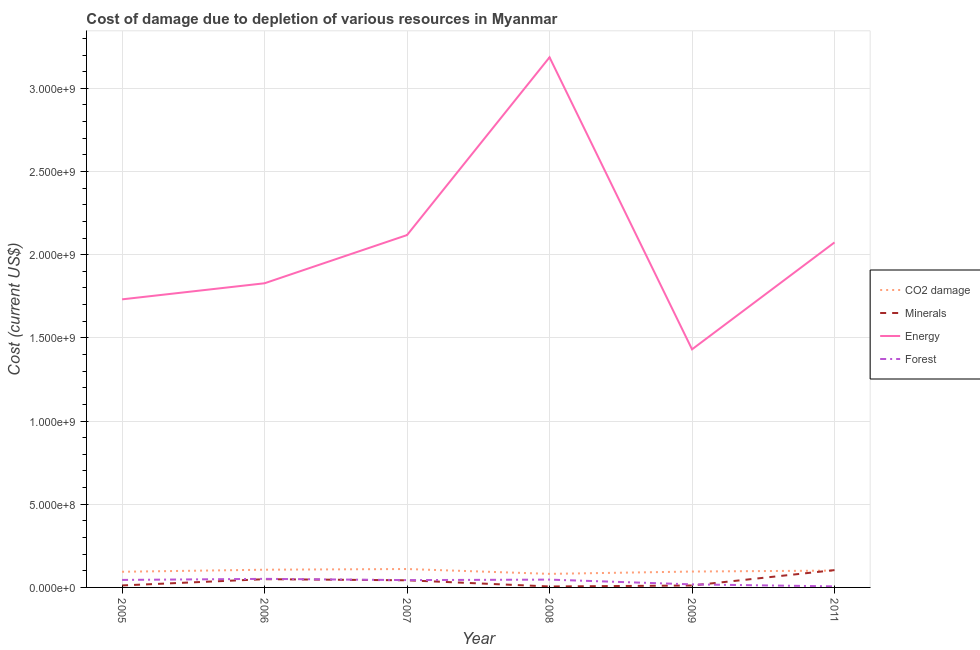How many different coloured lines are there?
Ensure brevity in your answer.  4. What is the cost of damage due to depletion of coal in 2008?
Give a very brief answer. 8.15e+07. Across all years, what is the maximum cost of damage due to depletion of minerals?
Your answer should be compact. 1.04e+08. Across all years, what is the minimum cost of damage due to depletion of minerals?
Provide a short and direct response. 5.68e+06. In which year was the cost of damage due to depletion of forests minimum?
Your answer should be compact. 2011. What is the total cost of damage due to depletion of energy in the graph?
Give a very brief answer. 1.24e+1. What is the difference between the cost of damage due to depletion of forests in 2006 and that in 2007?
Offer a terse response. 7.51e+06. What is the difference between the cost of damage due to depletion of forests in 2009 and the cost of damage due to depletion of minerals in 2006?
Keep it short and to the point. -3.12e+07. What is the average cost of damage due to depletion of forests per year?
Your response must be concise. 3.54e+07. In the year 2005, what is the difference between the cost of damage due to depletion of energy and cost of damage due to depletion of coal?
Give a very brief answer. 1.64e+09. In how many years, is the cost of damage due to depletion of coal greater than 2000000000 US$?
Offer a terse response. 0. What is the ratio of the cost of damage due to depletion of coal in 2006 to that in 2008?
Ensure brevity in your answer.  1.31. Is the cost of damage due to depletion of minerals in 2007 less than that in 2008?
Provide a short and direct response. No. Is the difference between the cost of damage due to depletion of coal in 2007 and 2011 greater than the difference between the cost of damage due to depletion of forests in 2007 and 2011?
Keep it short and to the point. No. What is the difference between the highest and the second highest cost of damage due to depletion of coal?
Give a very brief answer. 4.21e+06. What is the difference between the highest and the lowest cost of damage due to depletion of coal?
Ensure brevity in your answer.  2.92e+07. Is it the case that in every year, the sum of the cost of damage due to depletion of coal and cost of damage due to depletion of minerals is greater than the cost of damage due to depletion of energy?
Make the answer very short. No. Is the cost of damage due to depletion of minerals strictly greater than the cost of damage due to depletion of forests over the years?
Your answer should be compact. No. Is the cost of damage due to depletion of coal strictly less than the cost of damage due to depletion of energy over the years?
Provide a short and direct response. Yes. How many years are there in the graph?
Your answer should be very brief. 6. Are the values on the major ticks of Y-axis written in scientific E-notation?
Provide a short and direct response. Yes. How are the legend labels stacked?
Give a very brief answer. Vertical. What is the title of the graph?
Provide a succinct answer. Cost of damage due to depletion of various resources in Myanmar . What is the label or title of the Y-axis?
Keep it short and to the point. Cost (current US$). What is the Cost (current US$) in CO2 damage in 2005?
Provide a succinct answer. 9.41e+07. What is the Cost (current US$) in Minerals in 2005?
Keep it short and to the point. 1.19e+07. What is the Cost (current US$) in Energy in 2005?
Offer a terse response. 1.73e+09. What is the Cost (current US$) of Forest in 2005?
Your answer should be compact. 4.51e+07. What is the Cost (current US$) of CO2 damage in 2006?
Your answer should be compact. 1.06e+08. What is the Cost (current US$) in Minerals in 2006?
Offer a terse response. 4.95e+07. What is the Cost (current US$) in Energy in 2006?
Your answer should be compact. 1.83e+09. What is the Cost (current US$) in Forest in 2006?
Offer a very short reply. 5.15e+07. What is the Cost (current US$) of CO2 damage in 2007?
Provide a short and direct response. 1.11e+08. What is the Cost (current US$) of Minerals in 2007?
Your response must be concise. 4.29e+07. What is the Cost (current US$) of Energy in 2007?
Your response must be concise. 2.12e+09. What is the Cost (current US$) of Forest in 2007?
Keep it short and to the point. 4.40e+07. What is the Cost (current US$) of CO2 damage in 2008?
Ensure brevity in your answer.  8.15e+07. What is the Cost (current US$) of Minerals in 2008?
Provide a short and direct response. 5.68e+06. What is the Cost (current US$) in Energy in 2008?
Provide a short and direct response. 3.19e+09. What is the Cost (current US$) in Forest in 2008?
Your answer should be very brief. 4.70e+07. What is the Cost (current US$) of CO2 damage in 2009?
Offer a very short reply. 9.55e+07. What is the Cost (current US$) of Minerals in 2009?
Keep it short and to the point. 1.15e+07. What is the Cost (current US$) in Energy in 2009?
Provide a succinct answer. 1.43e+09. What is the Cost (current US$) in Forest in 2009?
Provide a short and direct response. 1.83e+07. What is the Cost (current US$) of CO2 damage in 2011?
Ensure brevity in your answer.  1.01e+08. What is the Cost (current US$) of Minerals in 2011?
Your answer should be compact. 1.04e+08. What is the Cost (current US$) of Energy in 2011?
Provide a short and direct response. 2.07e+09. What is the Cost (current US$) in Forest in 2011?
Your answer should be compact. 6.26e+06. Across all years, what is the maximum Cost (current US$) in CO2 damage?
Offer a terse response. 1.11e+08. Across all years, what is the maximum Cost (current US$) of Minerals?
Make the answer very short. 1.04e+08. Across all years, what is the maximum Cost (current US$) of Energy?
Make the answer very short. 3.19e+09. Across all years, what is the maximum Cost (current US$) of Forest?
Offer a very short reply. 5.15e+07. Across all years, what is the minimum Cost (current US$) in CO2 damage?
Your answer should be compact. 8.15e+07. Across all years, what is the minimum Cost (current US$) in Minerals?
Offer a terse response. 5.68e+06. Across all years, what is the minimum Cost (current US$) of Energy?
Give a very brief answer. 1.43e+09. Across all years, what is the minimum Cost (current US$) of Forest?
Offer a very short reply. 6.26e+06. What is the total Cost (current US$) of CO2 damage in the graph?
Make the answer very short. 5.89e+08. What is the total Cost (current US$) of Minerals in the graph?
Your answer should be very brief. 2.26e+08. What is the total Cost (current US$) of Energy in the graph?
Offer a very short reply. 1.24e+1. What is the total Cost (current US$) of Forest in the graph?
Provide a short and direct response. 2.12e+08. What is the difference between the Cost (current US$) of CO2 damage in 2005 and that in 2006?
Offer a very short reply. -1.23e+07. What is the difference between the Cost (current US$) in Minerals in 2005 and that in 2006?
Make the answer very short. -3.76e+07. What is the difference between the Cost (current US$) in Energy in 2005 and that in 2006?
Your answer should be compact. -9.66e+07. What is the difference between the Cost (current US$) in Forest in 2005 and that in 2006?
Give a very brief answer. -6.45e+06. What is the difference between the Cost (current US$) in CO2 damage in 2005 and that in 2007?
Make the answer very short. -1.65e+07. What is the difference between the Cost (current US$) of Minerals in 2005 and that in 2007?
Make the answer very short. -3.10e+07. What is the difference between the Cost (current US$) in Energy in 2005 and that in 2007?
Provide a succinct answer. -3.86e+08. What is the difference between the Cost (current US$) in Forest in 2005 and that in 2007?
Your response must be concise. 1.06e+06. What is the difference between the Cost (current US$) of CO2 damage in 2005 and that in 2008?
Make the answer very short. 1.27e+07. What is the difference between the Cost (current US$) of Minerals in 2005 and that in 2008?
Provide a short and direct response. 6.21e+06. What is the difference between the Cost (current US$) in Energy in 2005 and that in 2008?
Keep it short and to the point. -1.45e+09. What is the difference between the Cost (current US$) of Forest in 2005 and that in 2008?
Keep it short and to the point. -1.88e+06. What is the difference between the Cost (current US$) in CO2 damage in 2005 and that in 2009?
Your answer should be very brief. -1.32e+06. What is the difference between the Cost (current US$) of Minerals in 2005 and that in 2009?
Make the answer very short. 3.67e+05. What is the difference between the Cost (current US$) of Energy in 2005 and that in 2009?
Give a very brief answer. 3.00e+08. What is the difference between the Cost (current US$) in Forest in 2005 and that in 2009?
Provide a succinct answer. 2.68e+07. What is the difference between the Cost (current US$) in CO2 damage in 2005 and that in 2011?
Give a very brief answer. -7.06e+06. What is the difference between the Cost (current US$) of Minerals in 2005 and that in 2011?
Keep it short and to the point. -9.21e+07. What is the difference between the Cost (current US$) in Energy in 2005 and that in 2011?
Give a very brief answer. -3.42e+08. What is the difference between the Cost (current US$) of Forest in 2005 and that in 2011?
Your answer should be very brief. 3.88e+07. What is the difference between the Cost (current US$) of CO2 damage in 2006 and that in 2007?
Ensure brevity in your answer.  -4.21e+06. What is the difference between the Cost (current US$) in Minerals in 2006 and that in 2007?
Keep it short and to the point. 6.64e+06. What is the difference between the Cost (current US$) in Energy in 2006 and that in 2007?
Keep it short and to the point. -2.90e+08. What is the difference between the Cost (current US$) of Forest in 2006 and that in 2007?
Ensure brevity in your answer.  7.51e+06. What is the difference between the Cost (current US$) of CO2 damage in 2006 and that in 2008?
Offer a terse response. 2.50e+07. What is the difference between the Cost (current US$) in Minerals in 2006 and that in 2008?
Keep it short and to the point. 4.39e+07. What is the difference between the Cost (current US$) of Energy in 2006 and that in 2008?
Your answer should be compact. -1.36e+09. What is the difference between the Cost (current US$) in Forest in 2006 and that in 2008?
Make the answer very short. 4.57e+06. What is the difference between the Cost (current US$) of CO2 damage in 2006 and that in 2009?
Your response must be concise. 1.10e+07. What is the difference between the Cost (current US$) of Minerals in 2006 and that in 2009?
Keep it short and to the point. 3.80e+07. What is the difference between the Cost (current US$) in Energy in 2006 and that in 2009?
Give a very brief answer. 3.97e+08. What is the difference between the Cost (current US$) of Forest in 2006 and that in 2009?
Your answer should be compact. 3.32e+07. What is the difference between the Cost (current US$) of CO2 damage in 2006 and that in 2011?
Make the answer very short. 5.27e+06. What is the difference between the Cost (current US$) of Minerals in 2006 and that in 2011?
Offer a terse response. -5.45e+07. What is the difference between the Cost (current US$) of Energy in 2006 and that in 2011?
Provide a succinct answer. -2.46e+08. What is the difference between the Cost (current US$) in Forest in 2006 and that in 2011?
Provide a succinct answer. 4.53e+07. What is the difference between the Cost (current US$) in CO2 damage in 2007 and that in 2008?
Ensure brevity in your answer.  2.92e+07. What is the difference between the Cost (current US$) of Minerals in 2007 and that in 2008?
Your answer should be compact. 3.72e+07. What is the difference between the Cost (current US$) of Energy in 2007 and that in 2008?
Provide a short and direct response. -1.07e+09. What is the difference between the Cost (current US$) of Forest in 2007 and that in 2008?
Provide a short and direct response. -2.94e+06. What is the difference between the Cost (current US$) of CO2 damage in 2007 and that in 2009?
Your answer should be compact. 1.52e+07. What is the difference between the Cost (current US$) of Minerals in 2007 and that in 2009?
Give a very brief answer. 3.14e+07. What is the difference between the Cost (current US$) of Energy in 2007 and that in 2009?
Give a very brief answer. 6.87e+08. What is the difference between the Cost (current US$) of Forest in 2007 and that in 2009?
Your answer should be very brief. 2.57e+07. What is the difference between the Cost (current US$) in CO2 damage in 2007 and that in 2011?
Ensure brevity in your answer.  9.48e+06. What is the difference between the Cost (current US$) of Minerals in 2007 and that in 2011?
Keep it short and to the point. -6.11e+07. What is the difference between the Cost (current US$) in Energy in 2007 and that in 2011?
Give a very brief answer. 4.41e+07. What is the difference between the Cost (current US$) in Forest in 2007 and that in 2011?
Your answer should be compact. 3.78e+07. What is the difference between the Cost (current US$) in CO2 damage in 2008 and that in 2009?
Make the answer very short. -1.40e+07. What is the difference between the Cost (current US$) of Minerals in 2008 and that in 2009?
Provide a succinct answer. -5.85e+06. What is the difference between the Cost (current US$) of Energy in 2008 and that in 2009?
Make the answer very short. 1.76e+09. What is the difference between the Cost (current US$) in Forest in 2008 and that in 2009?
Make the answer very short. 2.86e+07. What is the difference between the Cost (current US$) in CO2 damage in 2008 and that in 2011?
Provide a short and direct response. -1.97e+07. What is the difference between the Cost (current US$) in Minerals in 2008 and that in 2011?
Ensure brevity in your answer.  -9.83e+07. What is the difference between the Cost (current US$) of Energy in 2008 and that in 2011?
Your response must be concise. 1.11e+09. What is the difference between the Cost (current US$) of Forest in 2008 and that in 2011?
Give a very brief answer. 4.07e+07. What is the difference between the Cost (current US$) of CO2 damage in 2009 and that in 2011?
Offer a terse response. -5.74e+06. What is the difference between the Cost (current US$) of Minerals in 2009 and that in 2011?
Make the answer very short. -9.25e+07. What is the difference between the Cost (current US$) of Energy in 2009 and that in 2011?
Ensure brevity in your answer.  -6.43e+08. What is the difference between the Cost (current US$) of Forest in 2009 and that in 2011?
Offer a terse response. 1.21e+07. What is the difference between the Cost (current US$) in CO2 damage in 2005 and the Cost (current US$) in Minerals in 2006?
Offer a very short reply. 4.46e+07. What is the difference between the Cost (current US$) of CO2 damage in 2005 and the Cost (current US$) of Energy in 2006?
Make the answer very short. -1.73e+09. What is the difference between the Cost (current US$) in CO2 damage in 2005 and the Cost (current US$) in Forest in 2006?
Your answer should be very brief. 4.26e+07. What is the difference between the Cost (current US$) of Minerals in 2005 and the Cost (current US$) of Energy in 2006?
Give a very brief answer. -1.82e+09. What is the difference between the Cost (current US$) of Minerals in 2005 and the Cost (current US$) of Forest in 2006?
Your response must be concise. -3.96e+07. What is the difference between the Cost (current US$) in Energy in 2005 and the Cost (current US$) in Forest in 2006?
Give a very brief answer. 1.68e+09. What is the difference between the Cost (current US$) of CO2 damage in 2005 and the Cost (current US$) of Minerals in 2007?
Offer a very short reply. 5.12e+07. What is the difference between the Cost (current US$) in CO2 damage in 2005 and the Cost (current US$) in Energy in 2007?
Your answer should be very brief. -2.02e+09. What is the difference between the Cost (current US$) of CO2 damage in 2005 and the Cost (current US$) of Forest in 2007?
Ensure brevity in your answer.  5.01e+07. What is the difference between the Cost (current US$) of Minerals in 2005 and the Cost (current US$) of Energy in 2007?
Provide a succinct answer. -2.11e+09. What is the difference between the Cost (current US$) of Minerals in 2005 and the Cost (current US$) of Forest in 2007?
Provide a succinct answer. -3.21e+07. What is the difference between the Cost (current US$) in Energy in 2005 and the Cost (current US$) in Forest in 2007?
Offer a terse response. 1.69e+09. What is the difference between the Cost (current US$) of CO2 damage in 2005 and the Cost (current US$) of Minerals in 2008?
Give a very brief answer. 8.85e+07. What is the difference between the Cost (current US$) of CO2 damage in 2005 and the Cost (current US$) of Energy in 2008?
Make the answer very short. -3.09e+09. What is the difference between the Cost (current US$) of CO2 damage in 2005 and the Cost (current US$) of Forest in 2008?
Keep it short and to the point. 4.72e+07. What is the difference between the Cost (current US$) of Minerals in 2005 and the Cost (current US$) of Energy in 2008?
Your response must be concise. -3.17e+09. What is the difference between the Cost (current US$) in Minerals in 2005 and the Cost (current US$) in Forest in 2008?
Your response must be concise. -3.51e+07. What is the difference between the Cost (current US$) of Energy in 2005 and the Cost (current US$) of Forest in 2008?
Keep it short and to the point. 1.68e+09. What is the difference between the Cost (current US$) of CO2 damage in 2005 and the Cost (current US$) of Minerals in 2009?
Keep it short and to the point. 8.26e+07. What is the difference between the Cost (current US$) of CO2 damage in 2005 and the Cost (current US$) of Energy in 2009?
Keep it short and to the point. -1.34e+09. What is the difference between the Cost (current US$) in CO2 damage in 2005 and the Cost (current US$) in Forest in 2009?
Your answer should be very brief. 7.58e+07. What is the difference between the Cost (current US$) in Minerals in 2005 and the Cost (current US$) in Energy in 2009?
Offer a terse response. -1.42e+09. What is the difference between the Cost (current US$) of Minerals in 2005 and the Cost (current US$) of Forest in 2009?
Keep it short and to the point. -6.44e+06. What is the difference between the Cost (current US$) in Energy in 2005 and the Cost (current US$) in Forest in 2009?
Offer a very short reply. 1.71e+09. What is the difference between the Cost (current US$) in CO2 damage in 2005 and the Cost (current US$) in Minerals in 2011?
Your answer should be compact. -9.89e+06. What is the difference between the Cost (current US$) in CO2 damage in 2005 and the Cost (current US$) in Energy in 2011?
Offer a very short reply. -1.98e+09. What is the difference between the Cost (current US$) in CO2 damage in 2005 and the Cost (current US$) in Forest in 2011?
Your answer should be very brief. 8.79e+07. What is the difference between the Cost (current US$) of Minerals in 2005 and the Cost (current US$) of Energy in 2011?
Make the answer very short. -2.06e+09. What is the difference between the Cost (current US$) in Minerals in 2005 and the Cost (current US$) in Forest in 2011?
Give a very brief answer. 5.64e+06. What is the difference between the Cost (current US$) of Energy in 2005 and the Cost (current US$) of Forest in 2011?
Your answer should be compact. 1.73e+09. What is the difference between the Cost (current US$) of CO2 damage in 2006 and the Cost (current US$) of Minerals in 2007?
Provide a succinct answer. 6.36e+07. What is the difference between the Cost (current US$) in CO2 damage in 2006 and the Cost (current US$) in Energy in 2007?
Give a very brief answer. -2.01e+09. What is the difference between the Cost (current US$) of CO2 damage in 2006 and the Cost (current US$) of Forest in 2007?
Your answer should be compact. 6.24e+07. What is the difference between the Cost (current US$) of Minerals in 2006 and the Cost (current US$) of Energy in 2007?
Offer a terse response. -2.07e+09. What is the difference between the Cost (current US$) in Minerals in 2006 and the Cost (current US$) in Forest in 2007?
Your answer should be compact. 5.51e+06. What is the difference between the Cost (current US$) in Energy in 2006 and the Cost (current US$) in Forest in 2007?
Provide a short and direct response. 1.78e+09. What is the difference between the Cost (current US$) of CO2 damage in 2006 and the Cost (current US$) of Minerals in 2008?
Offer a very short reply. 1.01e+08. What is the difference between the Cost (current US$) of CO2 damage in 2006 and the Cost (current US$) of Energy in 2008?
Offer a terse response. -3.08e+09. What is the difference between the Cost (current US$) of CO2 damage in 2006 and the Cost (current US$) of Forest in 2008?
Offer a terse response. 5.95e+07. What is the difference between the Cost (current US$) in Minerals in 2006 and the Cost (current US$) in Energy in 2008?
Provide a succinct answer. -3.14e+09. What is the difference between the Cost (current US$) in Minerals in 2006 and the Cost (current US$) in Forest in 2008?
Your answer should be very brief. 2.57e+06. What is the difference between the Cost (current US$) of Energy in 2006 and the Cost (current US$) of Forest in 2008?
Provide a short and direct response. 1.78e+09. What is the difference between the Cost (current US$) in CO2 damage in 2006 and the Cost (current US$) in Minerals in 2009?
Make the answer very short. 9.49e+07. What is the difference between the Cost (current US$) in CO2 damage in 2006 and the Cost (current US$) in Energy in 2009?
Make the answer very short. -1.32e+09. What is the difference between the Cost (current US$) in CO2 damage in 2006 and the Cost (current US$) in Forest in 2009?
Offer a very short reply. 8.81e+07. What is the difference between the Cost (current US$) of Minerals in 2006 and the Cost (current US$) of Energy in 2009?
Your answer should be very brief. -1.38e+09. What is the difference between the Cost (current US$) of Minerals in 2006 and the Cost (current US$) of Forest in 2009?
Provide a short and direct response. 3.12e+07. What is the difference between the Cost (current US$) of Energy in 2006 and the Cost (current US$) of Forest in 2009?
Your answer should be compact. 1.81e+09. What is the difference between the Cost (current US$) of CO2 damage in 2006 and the Cost (current US$) of Minerals in 2011?
Provide a short and direct response. 2.44e+06. What is the difference between the Cost (current US$) of CO2 damage in 2006 and the Cost (current US$) of Energy in 2011?
Provide a short and direct response. -1.97e+09. What is the difference between the Cost (current US$) in CO2 damage in 2006 and the Cost (current US$) in Forest in 2011?
Offer a terse response. 1.00e+08. What is the difference between the Cost (current US$) in Minerals in 2006 and the Cost (current US$) in Energy in 2011?
Your response must be concise. -2.02e+09. What is the difference between the Cost (current US$) of Minerals in 2006 and the Cost (current US$) of Forest in 2011?
Your answer should be compact. 4.33e+07. What is the difference between the Cost (current US$) in Energy in 2006 and the Cost (current US$) in Forest in 2011?
Ensure brevity in your answer.  1.82e+09. What is the difference between the Cost (current US$) in CO2 damage in 2007 and the Cost (current US$) in Minerals in 2008?
Make the answer very short. 1.05e+08. What is the difference between the Cost (current US$) in CO2 damage in 2007 and the Cost (current US$) in Energy in 2008?
Give a very brief answer. -3.08e+09. What is the difference between the Cost (current US$) in CO2 damage in 2007 and the Cost (current US$) in Forest in 2008?
Keep it short and to the point. 6.37e+07. What is the difference between the Cost (current US$) in Minerals in 2007 and the Cost (current US$) in Energy in 2008?
Make the answer very short. -3.14e+09. What is the difference between the Cost (current US$) in Minerals in 2007 and the Cost (current US$) in Forest in 2008?
Your answer should be compact. -4.07e+06. What is the difference between the Cost (current US$) of Energy in 2007 and the Cost (current US$) of Forest in 2008?
Give a very brief answer. 2.07e+09. What is the difference between the Cost (current US$) in CO2 damage in 2007 and the Cost (current US$) in Minerals in 2009?
Make the answer very short. 9.91e+07. What is the difference between the Cost (current US$) of CO2 damage in 2007 and the Cost (current US$) of Energy in 2009?
Your answer should be compact. -1.32e+09. What is the difference between the Cost (current US$) of CO2 damage in 2007 and the Cost (current US$) of Forest in 2009?
Keep it short and to the point. 9.23e+07. What is the difference between the Cost (current US$) of Minerals in 2007 and the Cost (current US$) of Energy in 2009?
Make the answer very short. -1.39e+09. What is the difference between the Cost (current US$) in Minerals in 2007 and the Cost (current US$) in Forest in 2009?
Your answer should be very brief. 2.46e+07. What is the difference between the Cost (current US$) of Energy in 2007 and the Cost (current US$) of Forest in 2009?
Offer a very short reply. 2.10e+09. What is the difference between the Cost (current US$) in CO2 damage in 2007 and the Cost (current US$) in Minerals in 2011?
Make the answer very short. 6.65e+06. What is the difference between the Cost (current US$) in CO2 damage in 2007 and the Cost (current US$) in Energy in 2011?
Provide a short and direct response. -1.96e+09. What is the difference between the Cost (current US$) of CO2 damage in 2007 and the Cost (current US$) of Forest in 2011?
Offer a terse response. 1.04e+08. What is the difference between the Cost (current US$) of Minerals in 2007 and the Cost (current US$) of Energy in 2011?
Offer a terse response. -2.03e+09. What is the difference between the Cost (current US$) in Minerals in 2007 and the Cost (current US$) in Forest in 2011?
Offer a terse response. 3.66e+07. What is the difference between the Cost (current US$) in Energy in 2007 and the Cost (current US$) in Forest in 2011?
Provide a short and direct response. 2.11e+09. What is the difference between the Cost (current US$) in CO2 damage in 2008 and the Cost (current US$) in Minerals in 2009?
Provide a short and direct response. 6.99e+07. What is the difference between the Cost (current US$) in CO2 damage in 2008 and the Cost (current US$) in Energy in 2009?
Your answer should be very brief. -1.35e+09. What is the difference between the Cost (current US$) of CO2 damage in 2008 and the Cost (current US$) of Forest in 2009?
Keep it short and to the point. 6.31e+07. What is the difference between the Cost (current US$) of Minerals in 2008 and the Cost (current US$) of Energy in 2009?
Provide a succinct answer. -1.43e+09. What is the difference between the Cost (current US$) of Minerals in 2008 and the Cost (current US$) of Forest in 2009?
Make the answer very short. -1.27e+07. What is the difference between the Cost (current US$) of Energy in 2008 and the Cost (current US$) of Forest in 2009?
Provide a succinct answer. 3.17e+09. What is the difference between the Cost (current US$) of CO2 damage in 2008 and the Cost (current US$) of Minerals in 2011?
Offer a terse response. -2.26e+07. What is the difference between the Cost (current US$) of CO2 damage in 2008 and the Cost (current US$) of Energy in 2011?
Ensure brevity in your answer.  -1.99e+09. What is the difference between the Cost (current US$) in CO2 damage in 2008 and the Cost (current US$) in Forest in 2011?
Your answer should be compact. 7.52e+07. What is the difference between the Cost (current US$) in Minerals in 2008 and the Cost (current US$) in Energy in 2011?
Provide a short and direct response. -2.07e+09. What is the difference between the Cost (current US$) in Minerals in 2008 and the Cost (current US$) in Forest in 2011?
Offer a very short reply. -5.76e+05. What is the difference between the Cost (current US$) in Energy in 2008 and the Cost (current US$) in Forest in 2011?
Offer a very short reply. 3.18e+09. What is the difference between the Cost (current US$) in CO2 damage in 2009 and the Cost (current US$) in Minerals in 2011?
Ensure brevity in your answer.  -8.57e+06. What is the difference between the Cost (current US$) of CO2 damage in 2009 and the Cost (current US$) of Energy in 2011?
Provide a short and direct response. -1.98e+09. What is the difference between the Cost (current US$) in CO2 damage in 2009 and the Cost (current US$) in Forest in 2011?
Ensure brevity in your answer.  8.92e+07. What is the difference between the Cost (current US$) of Minerals in 2009 and the Cost (current US$) of Energy in 2011?
Your answer should be compact. -2.06e+09. What is the difference between the Cost (current US$) of Minerals in 2009 and the Cost (current US$) of Forest in 2011?
Provide a short and direct response. 5.27e+06. What is the difference between the Cost (current US$) of Energy in 2009 and the Cost (current US$) of Forest in 2011?
Give a very brief answer. 1.42e+09. What is the average Cost (current US$) in CO2 damage per year?
Offer a very short reply. 9.82e+07. What is the average Cost (current US$) in Minerals per year?
Provide a short and direct response. 3.76e+07. What is the average Cost (current US$) of Energy per year?
Your answer should be compact. 2.06e+09. What is the average Cost (current US$) in Forest per year?
Give a very brief answer. 3.54e+07. In the year 2005, what is the difference between the Cost (current US$) of CO2 damage and Cost (current US$) of Minerals?
Your response must be concise. 8.22e+07. In the year 2005, what is the difference between the Cost (current US$) in CO2 damage and Cost (current US$) in Energy?
Give a very brief answer. -1.64e+09. In the year 2005, what is the difference between the Cost (current US$) in CO2 damage and Cost (current US$) in Forest?
Offer a very short reply. 4.90e+07. In the year 2005, what is the difference between the Cost (current US$) in Minerals and Cost (current US$) in Energy?
Provide a short and direct response. -1.72e+09. In the year 2005, what is the difference between the Cost (current US$) in Minerals and Cost (current US$) in Forest?
Ensure brevity in your answer.  -3.32e+07. In the year 2005, what is the difference between the Cost (current US$) in Energy and Cost (current US$) in Forest?
Ensure brevity in your answer.  1.69e+09. In the year 2006, what is the difference between the Cost (current US$) in CO2 damage and Cost (current US$) in Minerals?
Provide a short and direct response. 5.69e+07. In the year 2006, what is the difference between the Cost (current US$) in CO2 damage and Cost (current US$) in Energy?
Your response must be concise. -1.72e+09. In the year 2006, what is the difference between the Cost (current US$) in CO2 damage and Cost (current US$) in Forest?
Ensure brevity in your answer.  5.49e+07. In the year 2006, what is the difference between the Cost (current US$) of Minerals and Cost (current US$) of Energy?
Your answer should be very brief. -1.78e+09. In the year 2006, what is the difference between the Cost (current US$) in Minerals and Cost (current US$) in Forest?
Your answer should be very brief. -2.00e+06. In the year 2006, what is the difference between the Cost (current US$) in Energy and Cost (current US$) in Forest?
Your response must be concise. 1.78e+09. In the year 2007, what is the difference between the Cost (current US$) of CO2 damage and Cost (current US$) of Minerals?
Keep it short and to the point. 6.78e+07. In the year 2007, what is the difference between the Cost (current US$) of CO2 damage and Cost (current US$) of Energy?
Ensure brevity in your answer.  -2.01e+09. In the year 2007, what is the difference between the Cost (current US$) in CO2 damage and Cost (current US$) in Forest?
Provide a succinct answer. 6.66e+07. In the year 2007, what is the difference between the Cost (current US$) in Minerals and Cost (current US$) in Energy?
Provide a short and direct response. -2.07e+09. In the year 2007, what is the difference between the Cost (current US$) in Minerals and Cost (current US$) in Forest?
Your answer should be very brief. -1.13e+06. In the year 2007, what is the difference between the Cost (current US$) of Energy and Cost (current US$) of Forest?
Your answer should be very brief. 2.07e+09. In the year 2008, what is the difference between the Cost (current US$) in CO2 damage and Cost (current US$) in Minerals?
Give a very brief answer. 7.58e+07. In the year 2008, what is the difference between the Cost (current US$) in CO2 damage and Cost (current US$) in Energy?
Your answer should be very brief. -3.10e+09. In the year 2008, what is the difference between the Cost (current US$) of CO2 damage and Cost (current US$) of Forest?
Your answer should be compact. 3.45e+07. In the year 2008, what is the difference between the Cost (current US$) of Minerals and Cost (current US$) of Energy?
Give a very brief answer. -3.18e+09. In the year 2008, what is the difference between the Cost (current US$) of Minerals and Cost (current US$) of Forest?
Your answer should be compact. -4.13e+07. In the year 2008, what is the difference between the Cost (current US$) of Energy and Cost (current US$) of Forest?
Make the answer very short. 3.14e+09. In the year 2009, what is the difference between the Cost (current US$) in CO2 damage and Cost (current US$) in Minerals?
Offer a very short reply. 8.39e+07. In the year 2009, what is the difference between the Cost (current US$) of CO2 damage and Cost (current US$) of Energy?
Offer a very short reply. -1.34e+09. In the year 2009, what is the difference between the Cost (current US$) of CO2 damage and Cost (current US$) of Forest?
Offer a very short reply. 7.71e+07. In the year 2009, what is the difference between the Cost (current US$) in Minerals and Cost (current US$) in Energy?
Ensure brevity in your answer.  -1.42e+09. In the year 2009, what is the difference between the Cost (current US$) in Minerals and Cost (current US$) in Forest?
Your response must be concise. -6.80e+06. In the year 2009, what is the difference between the Cost (current US$) of Energy and Cost (current US$) of Forest?
Ensure brevity in your answer.  1.41e+09. In the year 2011, what is the difference between the Cost (current US$) in CO2 damage and Cost (current US$) in Minerals?
Keep it short and to the point. -2.83e+06. In the year 2011, what is the difference between the Cost (current US$) in CO2 damage and Cost (current US$) in Energy?
Your answer should be compact. -1.97e+09. In the year 2011, what is the difference between the Cost (current US$) of CO2 damage and Cost (current US$) of Forest?
Ensure brevity in your answer.  9.49e+07. In the year 2011, what is the difference between the Cost (current US$) of Minerals and Cost (current US$) of Energy?
Provide a succinct answer. -1.97e+09. In the year 2011, what is the difference between the Cost (current US$) of Minerals and Cost (current US$) of Forest?
Provide a succinct answer. 9.78e+07. In the year 2011, what is the difference between the Cost (current US$) in Energy and Cost (current US$) in Forest?
Your response must be concise. 2.07e+09. What is the ratio of the Cost (current US$) in CO2 damage in 2005 to that in 2006?
Keep it short and to the point. 0.88. What is the ratio of the Cost (current US$) in Minerals in 2005 to that in 2006?
Your answer should be very brief. 0.24. What is the ratio of the Cost (current US$) in Energy in 2005 to that in 2006?
Keep it short and to the point. 0.95. What is the ratio of the Cost (current US$) in Forest in 2005 to that in 2006?
Make the answer very short. 0.87. What is the ratio of the Cost (current US$) in CO2 damage in 2005 to that in 2007?
Make the answer very short. 0.85. What is the ratio of the Cost (current US$) of Minerals in 2005 to that in 2007?
Keep it short and to the point. 0.28. What is the ratio of the Cost (current US$) in Energy in 2005 to that in 2007?
Provide a succinct answer. 0.82. What is the ratio of the Cost (current US$) of Forest in 2005 to that in 2007?
Your answer should be compact. 1.02. What is the ratio of the Cost (current US$) in CO2 damage in 2005 to that in 2008?
Make the answer very short. 1.16. What is the ratio of the Cost (current US$) in Minerals in 2005 to that in 2008?
Make the answer very short. 2.09. What is the ratio of the Cost (current US$) of Energy in 2005 to that in 2008?
Provide a succinct answer. 0.54. What is the ratio of the Cost (current US$) of CO2 damage in 2005 to that in 2009?
Offer a very short reply. 0.99. What is the ratio of the Cost (current US$) of Minerals in 2005 to that in 2009?
Keep it short and to the point. 1.03. What is the ratio of the Cost (current US$) in Energy in 2005 to that in 2009?
Offer a terse response. 1.21. What is the ratio of the Cost (current US$) in Forest in 2005 to that in 2009?
Offer a very short reply. 2.46. What is the ratio of the Cost (current US$) in CO2 damage in 2005 to that in 2011?
Provide a succinct answer. 0.93. What is the ratio of the Cost (current US$) of Minerals in 2005 to that in 2011?
Keep it short and to the point. 0.11. What is the ratio of the Cost (current US$) in Energy in 2005 to that in 2011?
Keep it short and to the point. 0.83. What is the ratio of the Cost (current US$) of Forest in 2005 to that in 2011?
Offer a very short reply. 7.2. What is the ratio of the Cost (current US$) in CO2 damage in 2006 to that in 2007?
Your answer should be very brief. 0.96. What is the ratio of the Cost (current US$) in Minerals in 2006 to that in 2007?
Provide a short and direct response. 1.15. What is the ratio of the Cost (current US$) in Energy in 2006 to that in 2007?
Ensure brevity in your answer.  0.86. What is the ratio of the Cost (current US$) of Forest in 2006 to that in 2007?
Offer a terse response. 1.17. What is the ratio of the Cost (current US$) of CO2 damage in 2006 to that in 2008?
Give a very brief answer. 1.31. What is the ratio of the Cost (current US$) of Minerals in 2006 to that in 2008?
Offer a terse response. 8.72. What is the ratio of the Cost (current US$) of Energy in 2006 to that in 2008?
Make the answer very short. 0.57. What is the ratio of the Cost (current US$) of Forest in 2006 to that in 2008?
Provide a short and direct response. 1.1. What is the ratio of the Cost (current US$) of CO2 damage in 2006 to that in 2009?
Provide a short and direct response. 1.12. What is the ratio of the Cost (current US$) in Minerals in 2006 to that in 2009?
Provide a succinct answer. 4.3. What is the ratio of the Cost (current US$) of Energy in 2006 to that in 2009?
Your answer should be very brief. 1.28. What is the ratio of the Cost (current US$) of Forest in 2006 to that in 2009?
Provide a succinct answer. 2.81. What is the ratio of the Cost (current US$) in CO2 damage in 2006 to that in 2011?
Your response must be concise. 1.05. What is the ratio of the Cost (current US$) in Minerals in 2006 to that in 2011?
Your answer should be compact. 0.48. What is the ratio of the Cost (current US$) in Energy in 2006 to that in 2011?
Provide a short and direct response. 0.88. What is the ratio of the Cost (current US$) of Forest in 2006 to that in 2011?
Provide a short and direct response. 8.23. What is the ratio of the Cost (current US$) in CO2 damage in 2007 to that in 2008?
Your answer should be very brief. 1.36. What is the ratio of the Cost (current US$) in Minerals in 2007 to that in 2008?
Make the answer very short. 7.55. What is the ratio of the Cost (current US$) of Energy in 2007 to that in 2008?
Keep it short and to the point. 0.66. What is the ratio of the Cost (current US$) of Forest in 2007 to that in 2008?
Your answer should be compact. 0.94. What is the ratio of the Cost (current US$) of CO2 damage in 2007 to that in 2009?
Provide a succinct answer. 1.16. What is the ratio of the Cost (current US$) in Minerals in 2007 to that in 2009?
Offer a very short reply. 3.72. What is the ratio of the Cost (current US$) in Energy in 2007 to that in 2009?
Offer a very short reply. 1.48. What is the ratio of the Cost (current US$) in Forest in 2007 to that in 2009?
Provide a short and direct response. 2.4. What is the ratio of the Cost (current US$) in CO2 damage in 2007 to that in 2011?
Your answer should be very brief. 1.09. What is the ratio of the Cost (current US$) in Minerals in 2007 to that in 2011?
Keep it short and to the point. 0.41. What is the ratio of the Cost (current US$) in Energy in 2007 to that in 2011?
Make the answer very short. 1.02. What is the ratio of the Cost (current US$) in Forest in 2007 to that in 2011?
Provide a short and direct response. 7.04. What is the ratio of the Cost (current US$) in CO2 damage in 2008 to that in 2009?
Make the answer very short. 0.85. What is the ratio of the Cost (current US$) of Minerals in 2008 to that in 2009?
Provide a succinct answer. 0.49. What is the ratio of the Cost (current US$) in Energy in 2008 to that in 2009?
Ensure brevity in your answer.  2.23. What is the ratio of the Cost (current US$) of Forest in 2008 to that in 2009?
Provide a short and direct response. 2.56. What is the ratio of the Cost (current US$) in CO2 damage in 2008 to that in 2011?
Give a very brief answer. 0.81. What is the ratio of the Cost (current US$) in Minerals in 2008 to that in 2011?
Your answer should be very brief. 0.05. What is the ratio of the Cost (current US$) in Energy in 2008 to that in 2011?
Give a very brief answer. 1.54. What is the ratio of the Cost (current US$) of Forest in 2008 to that in 2011?
Your response must be concise. 7.51. What is the ratio of the Cost (current US$) of CO2 damage in 2009 to that in 2011?
Ensure brevity in your answer.  0.94. What is the ratio of the Cost (current US$) in Minerals in 2009 to that in 2011?
Offer a very short reply. 0.11. What is the ratio of the Cost (current US$) of Energy in 2009 to that in 2011?
Provide a succinct answer. 0.69. What is the ratio of the Cost (current US$) in Forest in 2009 to that in 2011?
Provide a short and direct response. 2.93. What is the difference between the highest and the second highest Cost (current US$) of CO2 damage?
Make the answer very short. 4.21e+06. What is the difference between the highest and the second highest Cost (current US$) of Minerals?
Your answer should be compact. 5.45e+07. What is the difference between the highest and the second highest Cost (current US$) of Energy?
Give a very brief answer. 1.07e+09. What is the difference between the highest and the second highest Cost (current US$) in Forest?
Offer a very short reply. 4.57e+06. What is the difference between the highest and the lowest Cost (current US$) in CO2 damage?
Your answer should be very brief. 2.92e+07. What is the difference between the highest and the lowest Cost (current US$) of Minerals?
Provide a short and direct response. 9.83e+07. What is the difference between the highest and the lowest Cost (current US$) of Energy?
Offer a terse response. 1.76e+09. What is the difference between the highest and the lowest Cost (current US$) in Forest?
Keep it short and to the point. 4.53e+07. 